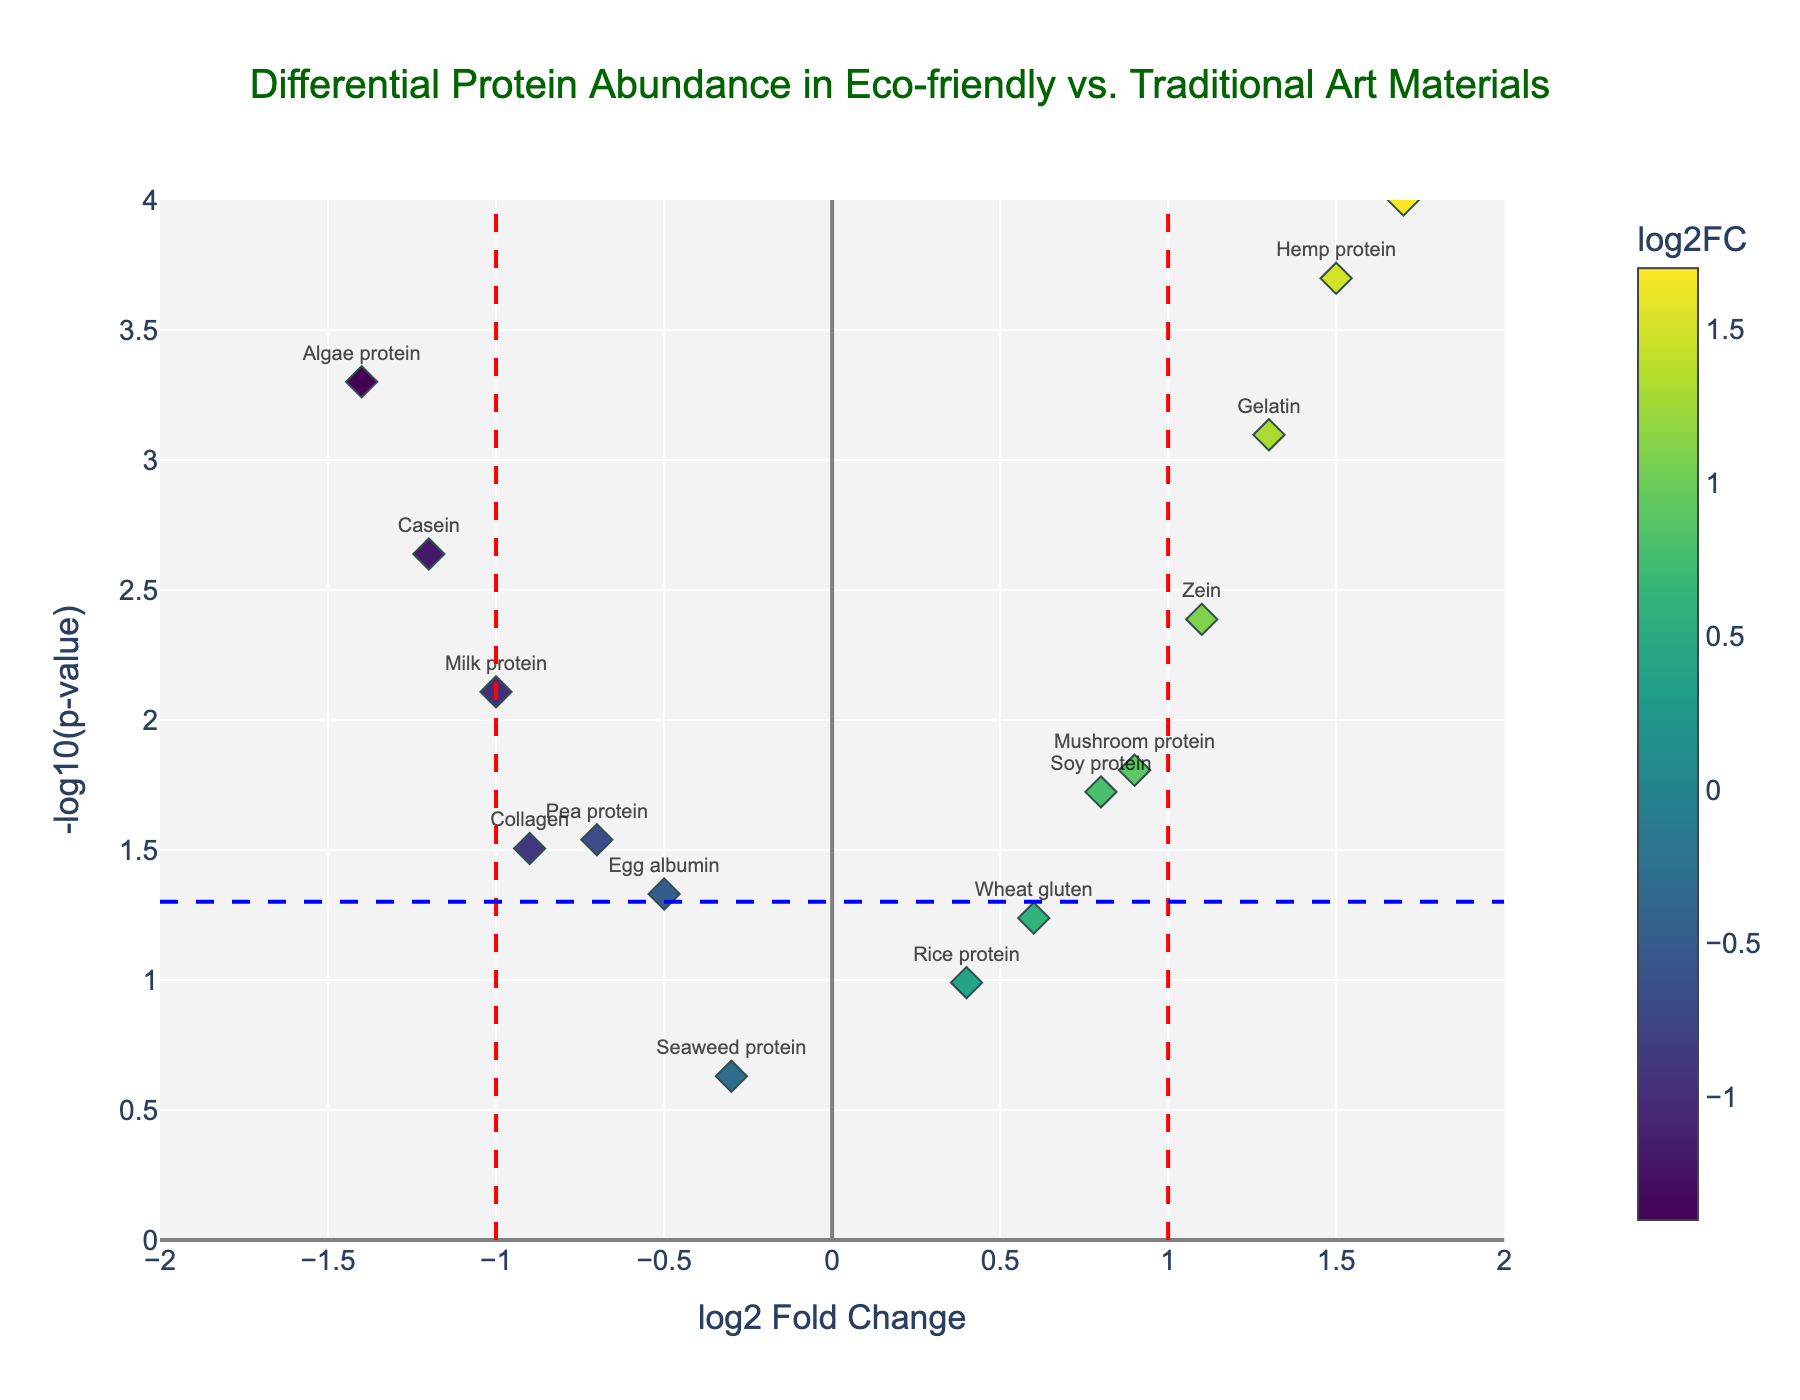what is the title of the plot? The title is prominently displayed at the top center of the plot, in a font size of 20 and color DarkGreen. It reads "Differential Protein Abundance in Eco-friendly vs. Traditional Art Materials."
Answer: Differential Protein Abundance in Eco-friendly vs. Traditional Art Materials What do the colors of the markers indicate? The color of the markers indicates the log2 fold change (log2FC) of each protein, with a color scale shown on the side. The colors range according to the Viridis colorscale.
Answer: log2 fold change Which protein shows the highest differential abundance? The protein with the highest value on the x-axis (log2FC) indicates the highest differential abundance. The most rightward point is Insect protein with a log2FC of 1.7.
Answer: Insect protein What do the dashed blue and red lines represent? The blue dashed line represents the significance threshold for the p-value, set at -log10(p-value) = -log10(0.05). The red dashed lines at log2FC = -1 and 1 indicate significant differential expression thresholds.
Answer: significance thresholds How many proteins are considered significantly differentially abundant? Proteins with p-values less than 0.05 and absolute log2FC greater than 1 are considered significantly differentially abundant. Visually counted, the proteins with values beyond the red and blue dashed lines are Casein, Gelatin, Zein, Hemp protein, Algae protein, and Insect protein.
Answer: 6 Which protein has the most negative log2 fold change? The protein with the lowest value on the x-axis (log2FC) reflects the most negative differential abundance, which is Algae protein with a log2FC of -1.4.
Answer: Algae protein Is there any protein that is just above the p-value significance threshold but with low fold change? Proteins near the blue dashed line but close to log2FC = 0 fit this question. Egg albumin (-0.5 log2FC, p-value = 0.0467) is just above the p-value threshold with a relatively low fold change.
Answer: Egg albumin What is the protein with the second-highest log2 fold change? We need to identify the second highest point on the x-axis. Hemp protein (1.5) is second to Insect protein (1.7).
Answer: Hemp protein 